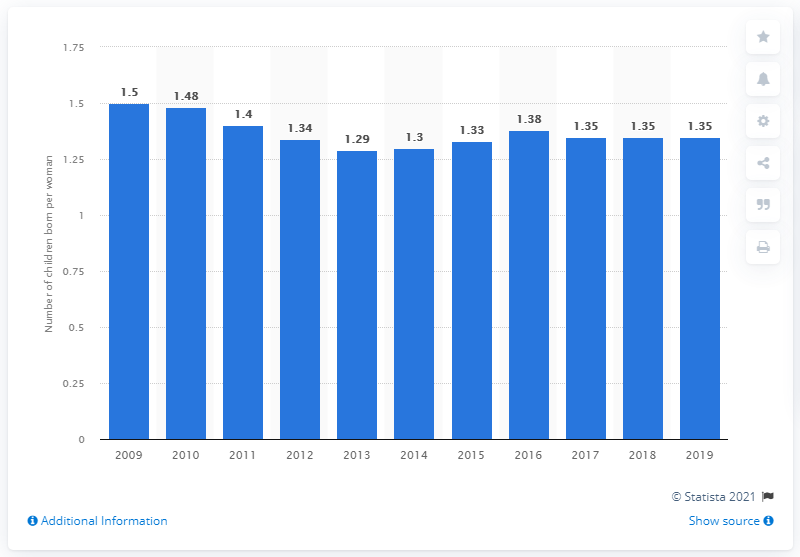Outline some significant characteristics in this image. In 2019, the fertility rate in Greece was 1.35. 